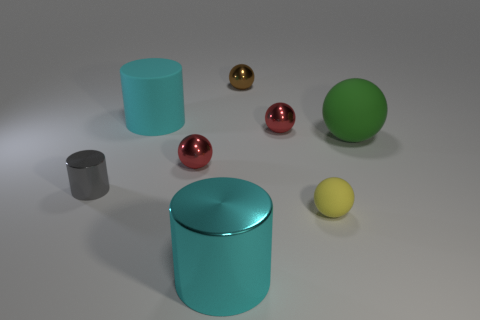Subtract all blue spheres. Subtract all blue cylinders. How many spheres are left? 5 Add 1 small yellow things. How many objects exist? 9 Subtract all cylinders. How many objects are left? 5 Add 6 large yellow rubber blocks. How many large yellow rubber blocks exist? 6 Subtract 0 red cylinders. How many objects are left? 8 Subtract all small gray cylinders. Subtract all large cyan matte cylinders. How many objects are left? 6 Add 2 small red objects. How many small red objects are left? 4 